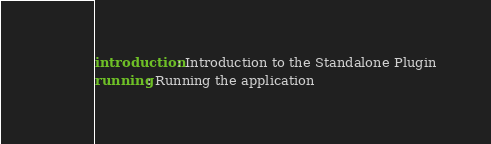Convert code to text. <code><loc_0><loc_0><loc_500><loc_500><_YAML_>introduction: Introduction to the Standalone Plugin
running: Running the application
</code> 